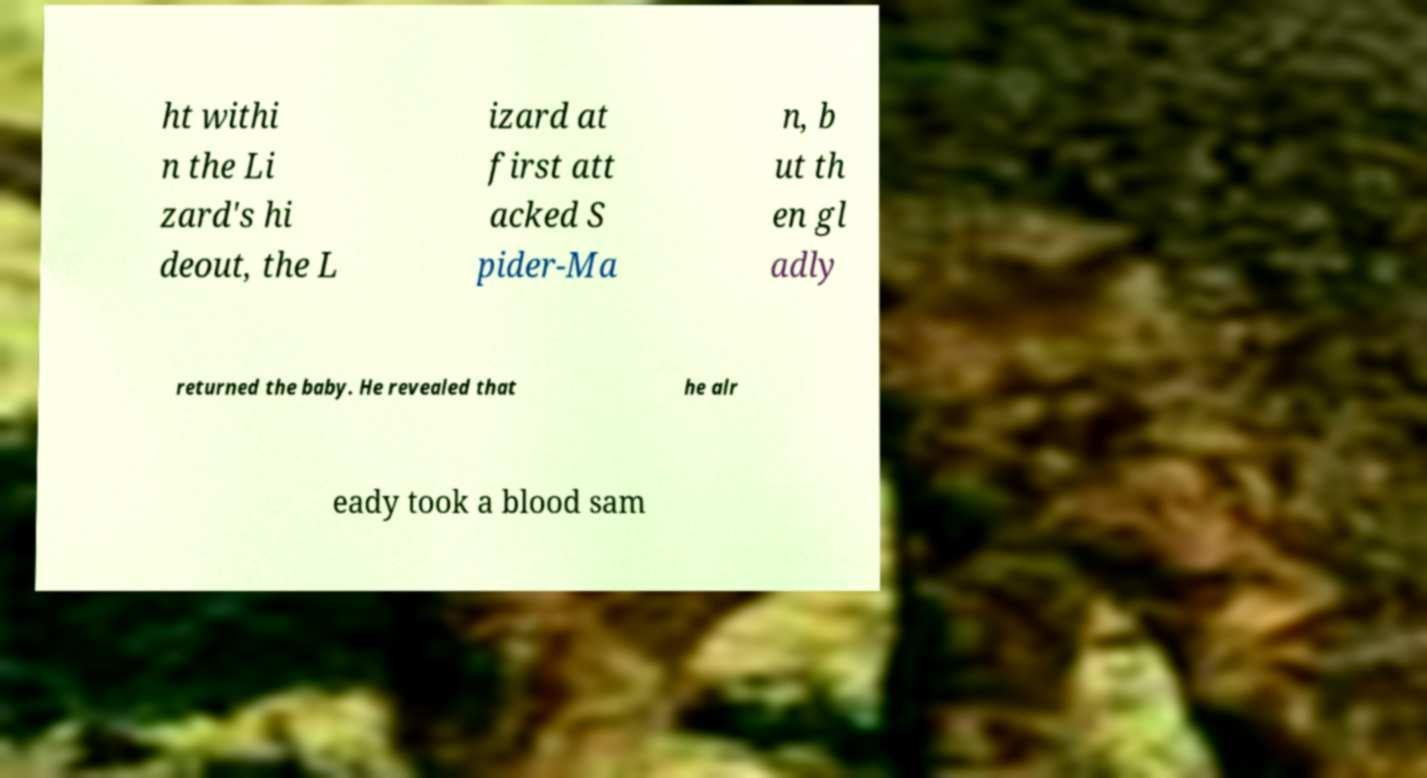For documentation purposes, I need the text within this image transcribed. Could you provide that? ht withi n the Li zard's hi deout, the L izard at first att acked S pider-Ma n, b ut th en gl adly returned the baby. He revealed that he alr eady took a blood sam 